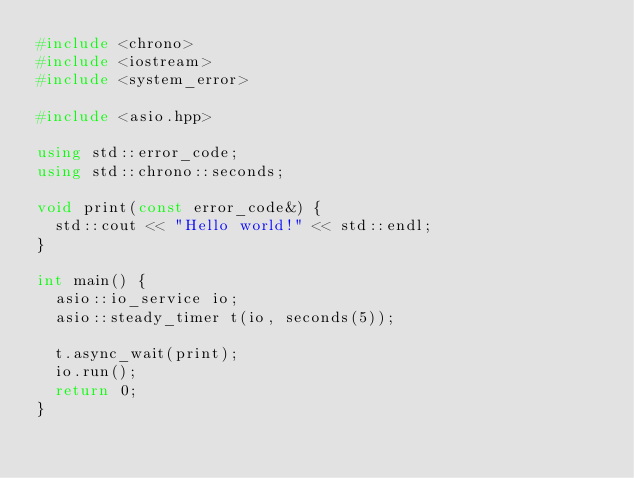Convert code to text. <code><loc_0><loc_0><loc_500><loc_500><_C++_>#include <chrono>
#include <iostream>
#include <system_error>

#include <asio.hpp>

using std::error_code;
using std::chrono::seconds;

void print(const error_code&) {
  std::cout << "Hello world!" << std::endl;
}

int main() {
  asio::io_service io;
  asio::steady_timer t(io, seconds(5));

  t.async_wait(print);
  io.run();
  return 0;
}
</code> 